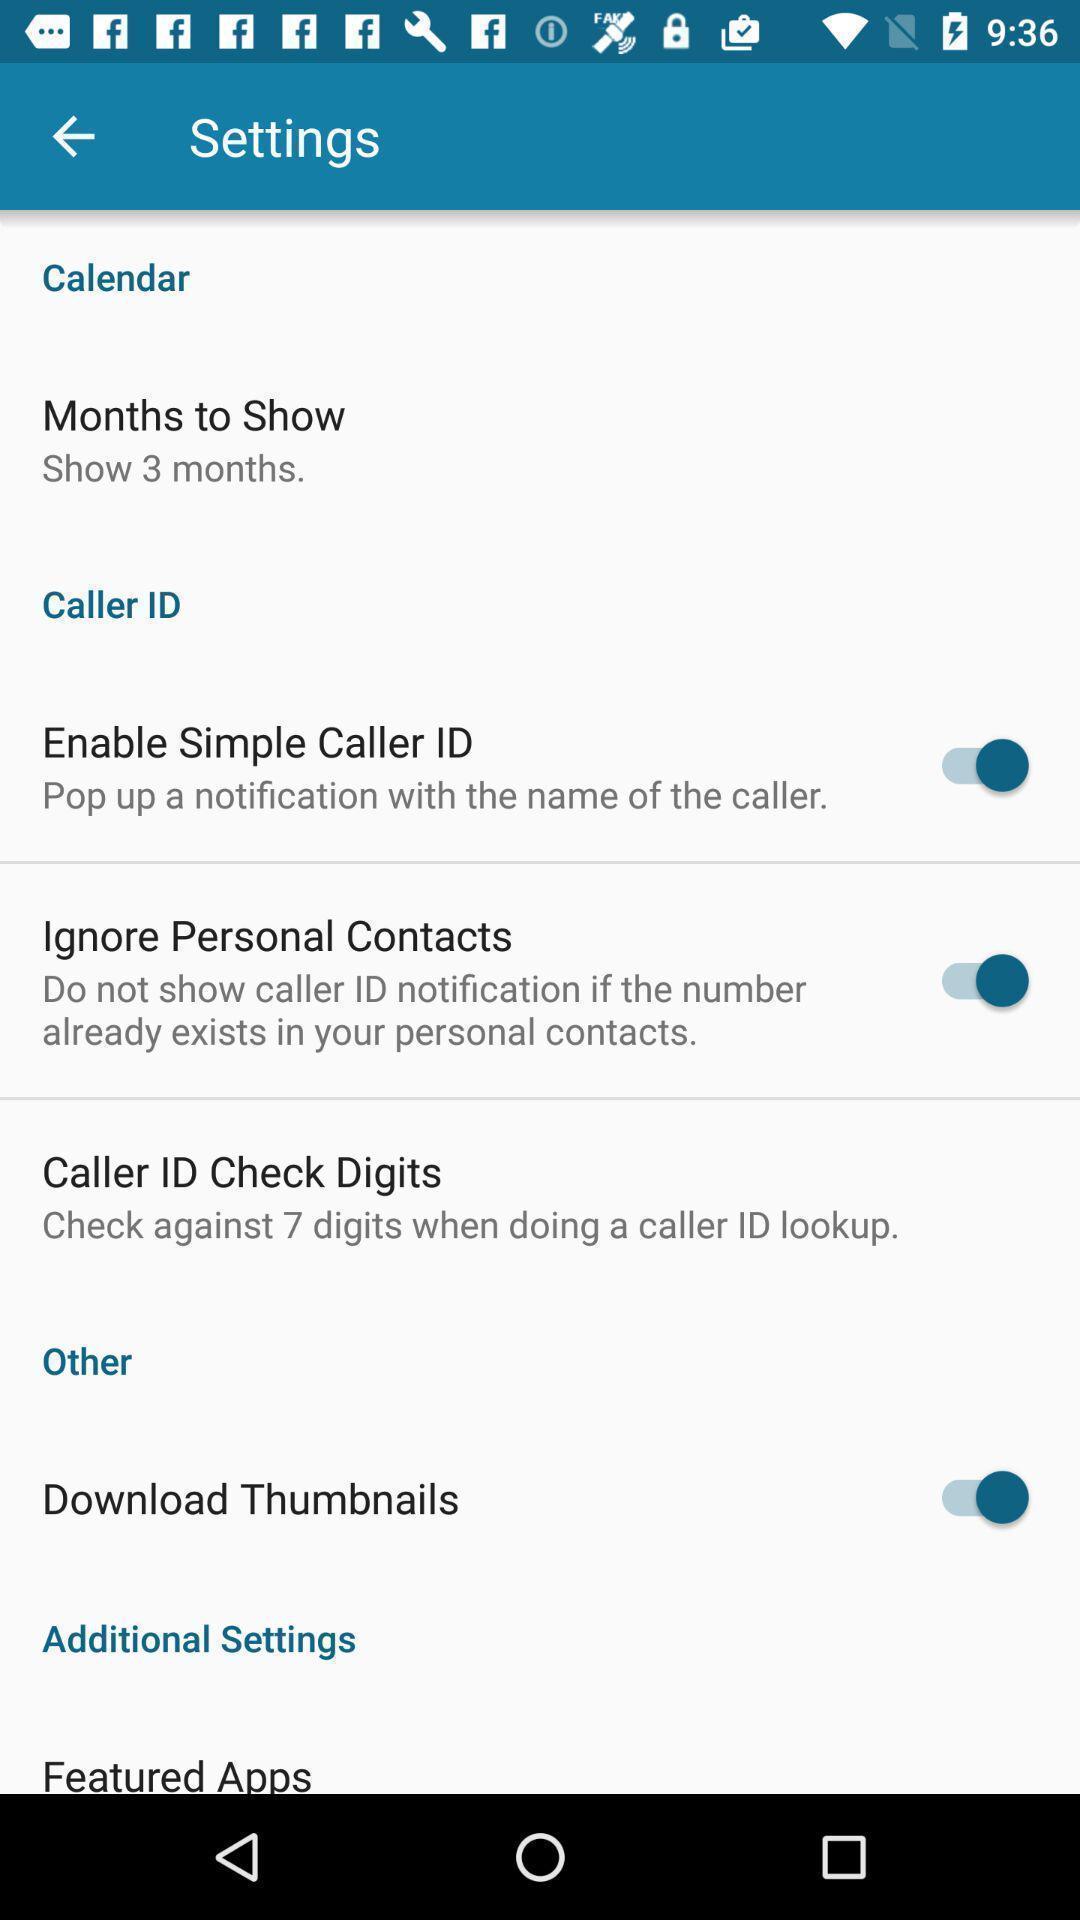Explain the elements present in this screenshot. Settings page displaying. 